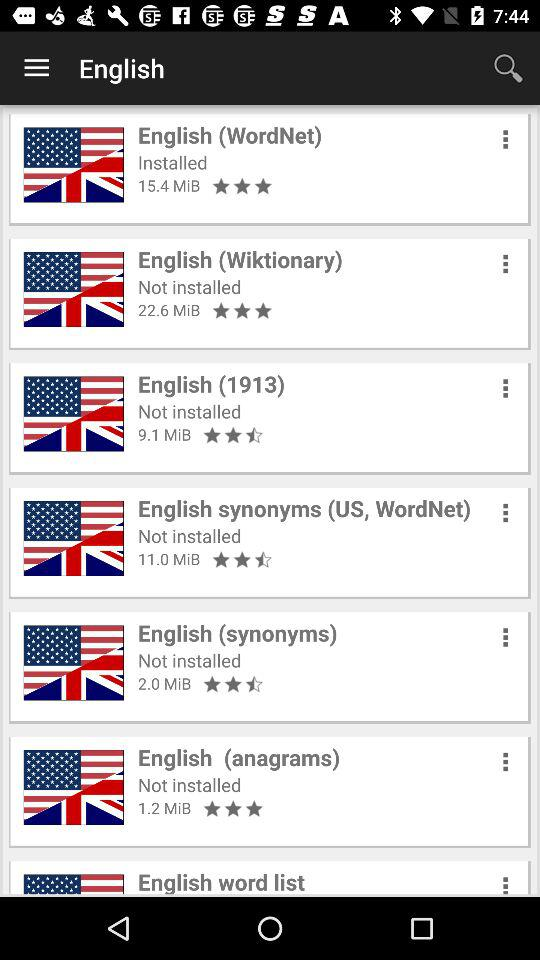Which app is installed? The installed app is "English (WordNet)". 